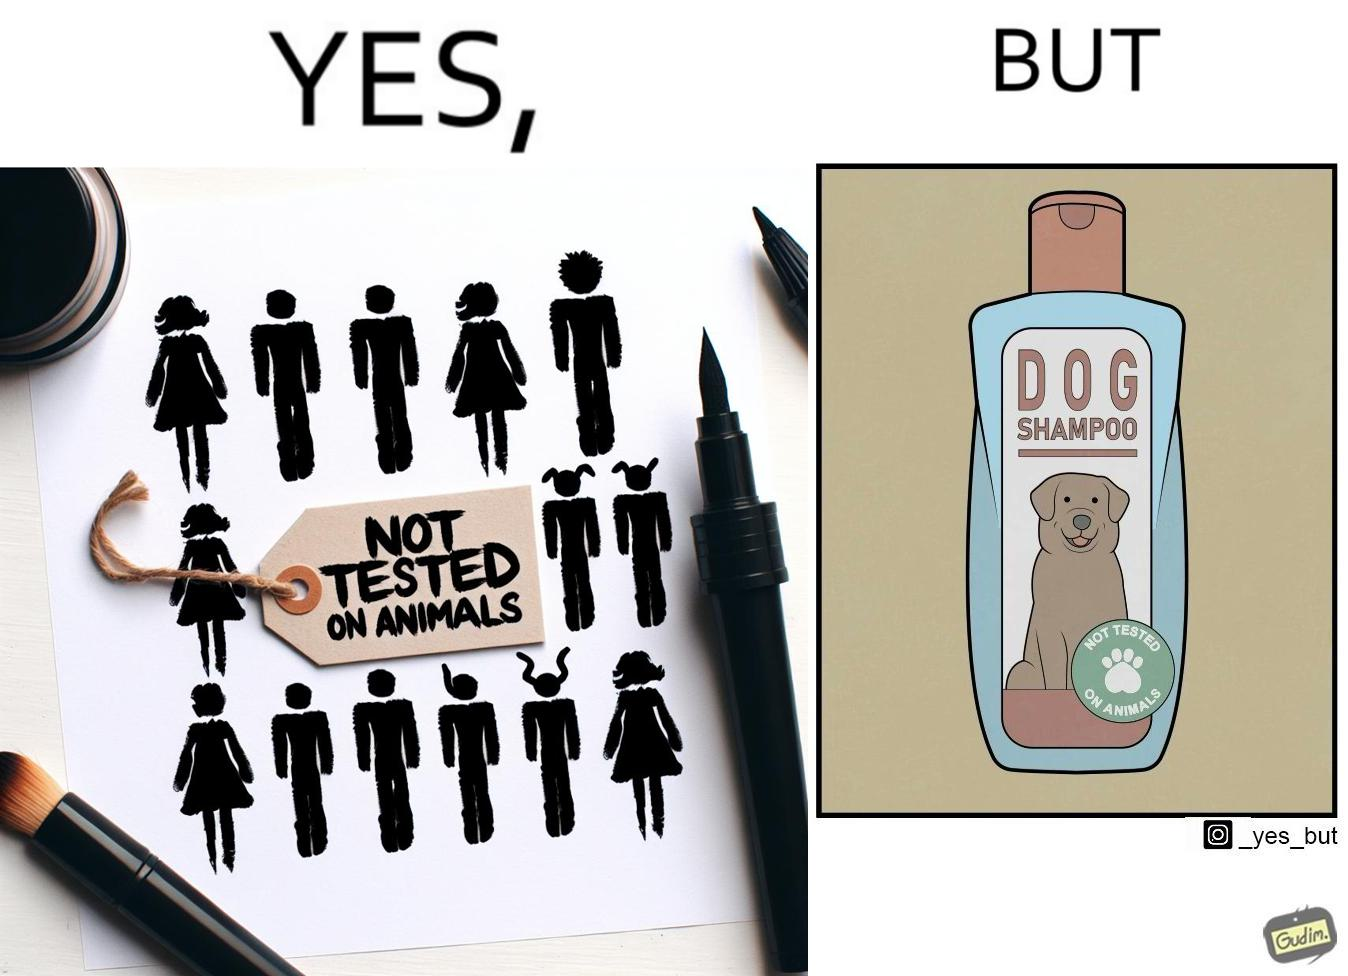What does this image depict? The images are ironic since a dog shampoo bottle has a sticker indicating that it has not been tested on animals and hence might not be safe for animal use. It is amusing that a product designed to be used by animals is not tested on animals for their safety 